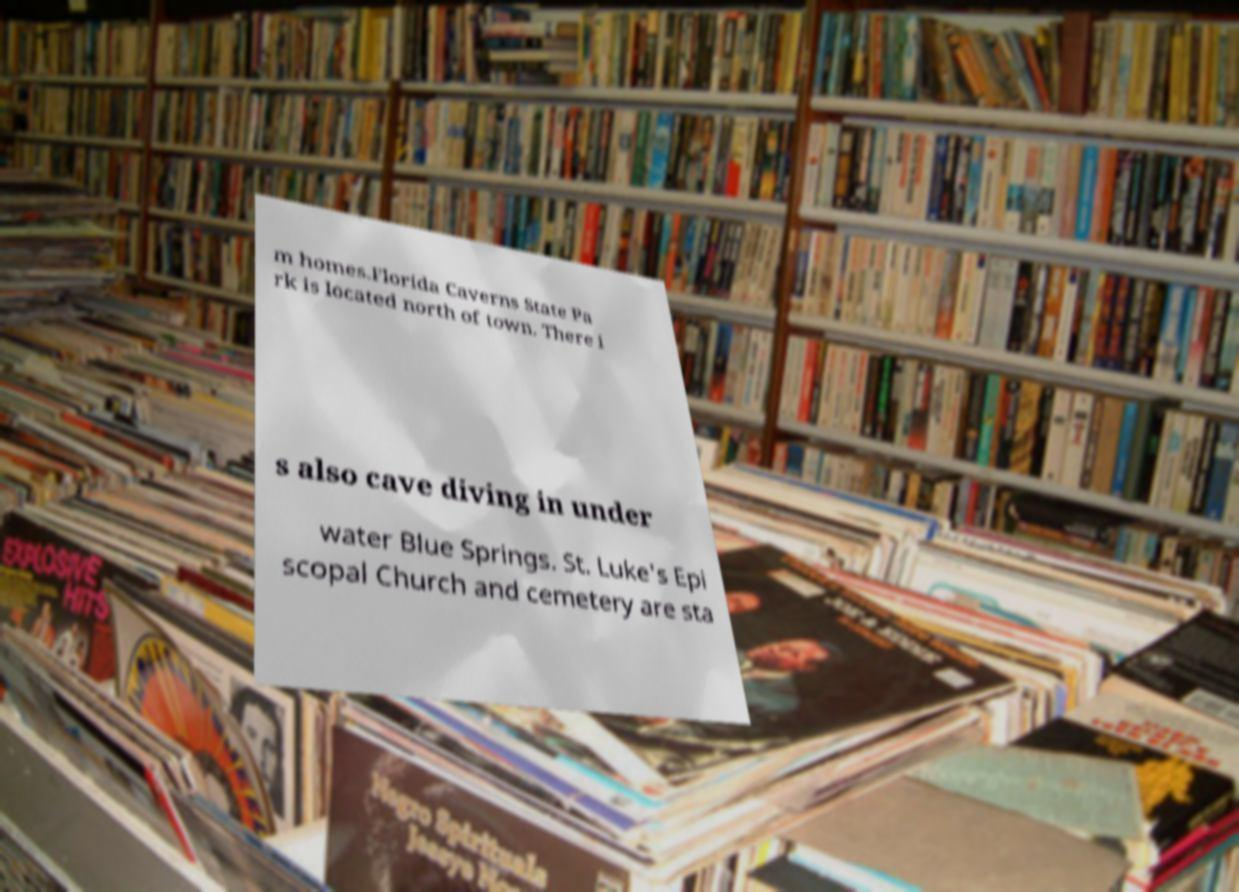Could you extract and type out the text from this image? m homes.Florida Caverns State Pa rk is located north of town. There i s also cave diving in under water Blue Springs. St. Luke's Epi scopal Church and cemetery are sta 